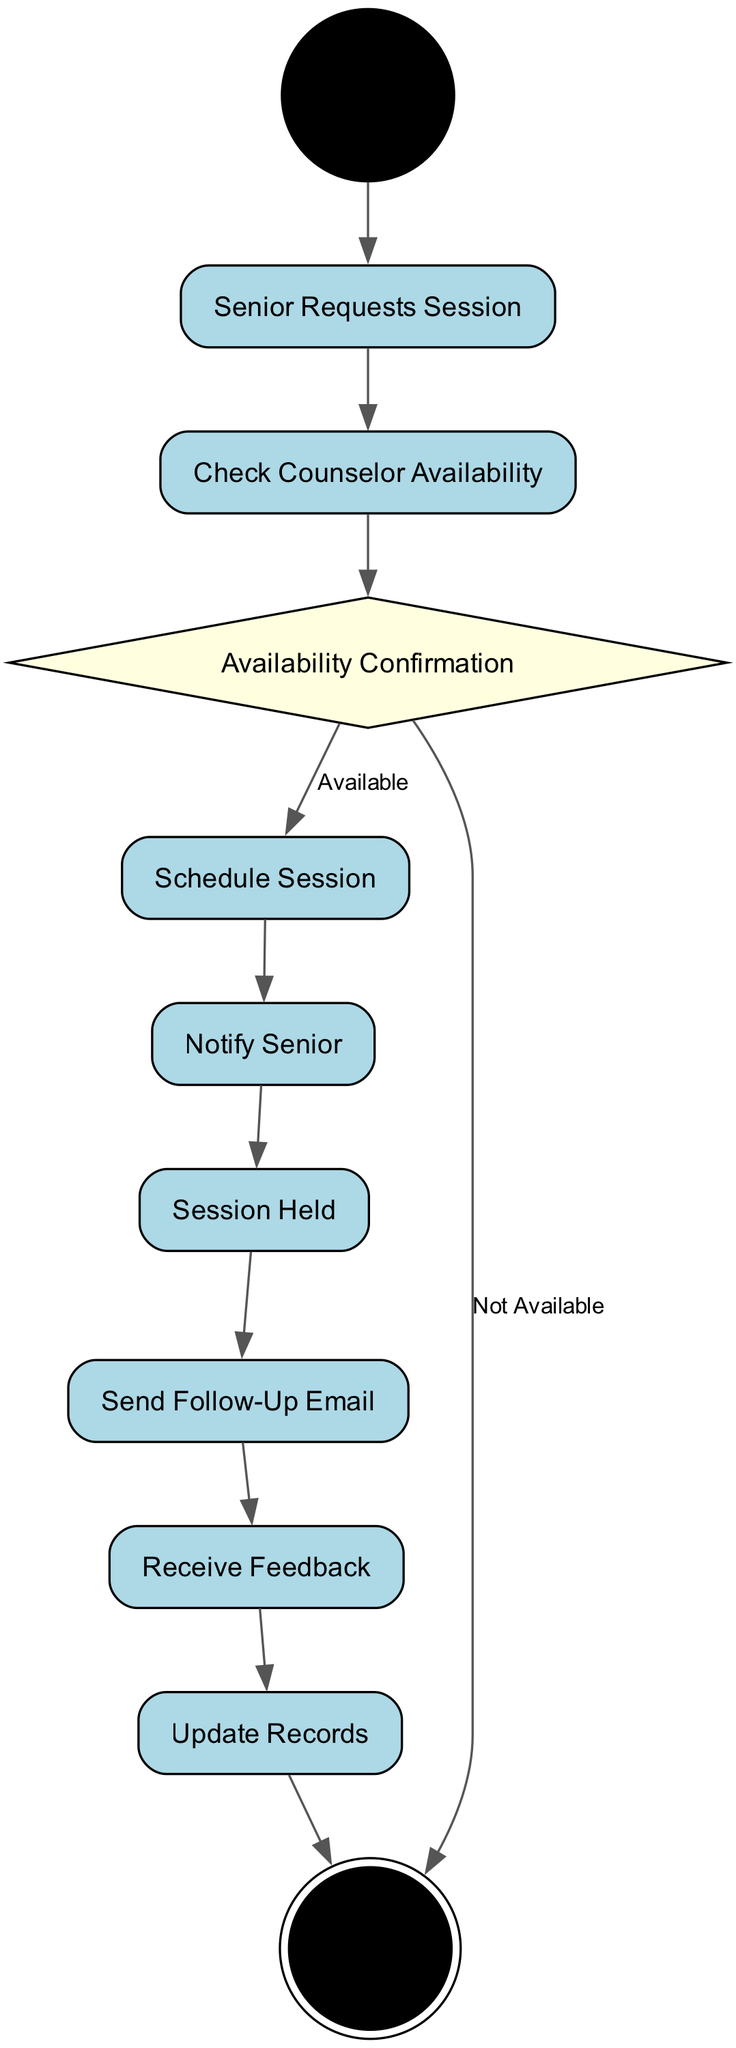What is the first action in the diagram? The first action after the "Start" node is "Senior Requests Session." This follows directly after the initial node, marking the beginning of the session scheduling process.
Answer: Senior Requests Session How many actions are there in total? The diagram contains six actions: "Senior Requests Session," "Check Counselor Availability," "Schedule Session," "Notify Senior," "Session Held," and "Send Follow-Up Email." Counting all actions gives a total of six.
Answer: Six What happens if the counselor is not available? If the counselor is not available, the flow transitions from "Availability Confirmation" to the "End" node. This indicates that no further steps will be taken in the session scheduling process.
Answer: End Which node follows "Send Follow-Up Email"? The node that follows "Send Follow-Up Email" is "Receive Feedback." This shows the continuation of the process after the follow-up action has been executed.
Answer: Receive Feedback How many decisions are present in the diagram? There is one decision node in the diagram, labeled "Availability Confirmation." This node determines whether or not the counselor is available, leading to two possible paths.
Answer: One What action occurs immediately after the session is held? Immediately after the session is held, the action "Send Follow-Up Email" occurs. This allows for additional communication with the senior client following the session.
Answer: Send Follow-Up Email What are the possible outcomes from the "Availability Confirmation" node? The "Availability Confirmation" node leads to two outcomes: "Schedule Session" if the counselor is available and "End" if the counselor is not available. This highlights the decision-making process based on counselor availability.
Answer: Schedule Session, End Which action is responsible for updating records? The action responsible for updating records is "Update Records," which occurs after receiving feedback from the senior. This step is crucial for maintaining accurate records of the counseling sessions.
Answer: Update Records 